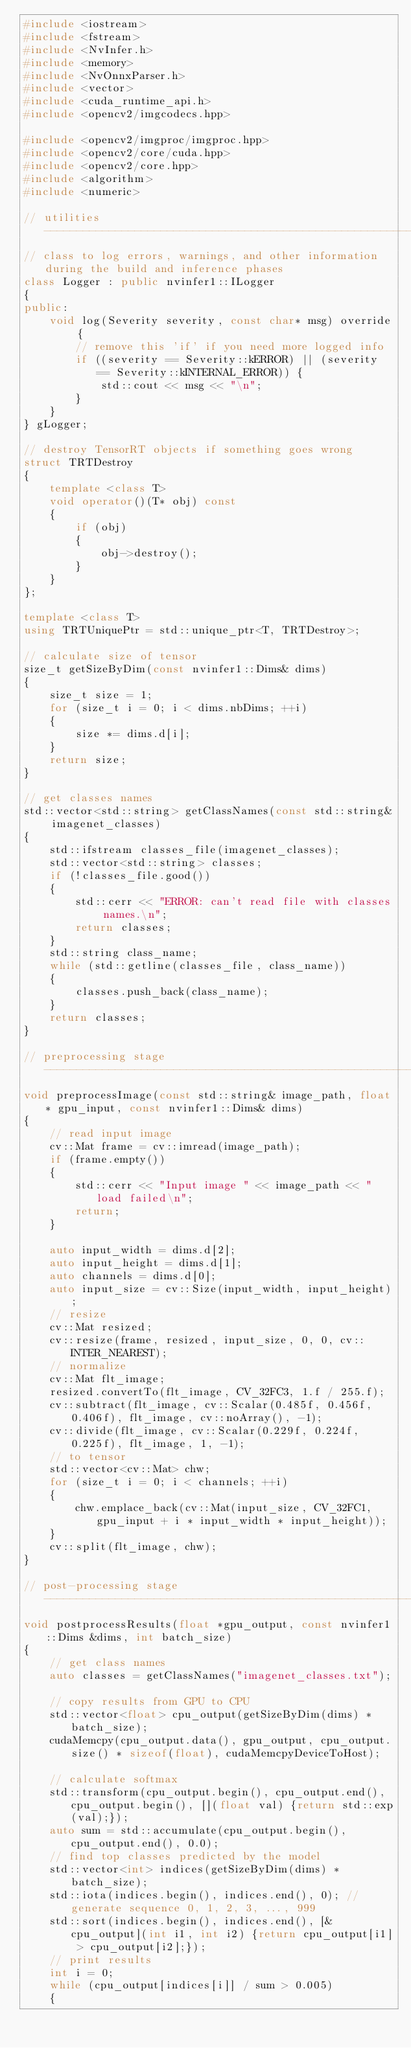Convert code to text. <code><loc_0><loc_0><loc_500><loc_500><_C++_>#include <iostream>
#include <fstream>
#include <NvInfer.h>
#include <memory>
#include <NvOnnxParser.h>
#include <vector>
#include <cuda_runtime_api.h>
#include <opencv2/imgcodecs.hpp>

#include <opencv2/imgproc/imgproc.hpp>
#include <opencv2/core/cuda.hpp>
#include <opencv2/core.hpp>
#include <algorithm>
#include <numeric>

// utilities ----------------------------------------------------------------------------------------------------------
// class to log errors, warnings, and other information during the build and inference phases
class Logger : public nvinfer1::ILogger
{
public:
    void log(Severity severity, const char* msg) override {
        // remove this 'if' if you need more logged info
        if ((severity == Severity::kERROR) || (severity == Severity::kINTERNAL_ERROR)) {
            std::cout << msg << "\n";
        }
    }
} gLogger;

// destroy TensorRT objects if something goes wrong
struct TRTDestroy
{
    template <class T>
    void operator()(T* obj) const
    {
        if (obj)
        {
            obj->destroy();
        }
    }
};

template <class T>
using TRTUniquePtr = std::unique_ptr<T, TRTDestroy>;

// calculate size of tensor
size_t getSizeByDim(const nvinfer1::Dims& dims)
{
    size_t size = 1;
    for (size_t i = 0; i < dims.nbDims; ++i)
    {
        size *= dims.d[i];
    }
    return size;
}

// get classes names
std::vector<std::string> getClassNames(const std::string& imagenet_classes)
{
    std::ifstream classes_file(imagenet_classes);
    std::vector<std::string> classes;
    if (!classes_file.good())
    {
        std::cerr << "ERROR: can't read file with classes names.\n";
        return classes;
    }
    std::string class_name;
    while (std::getline(classes_file, class_name))
    {
        classes.push_back(class_name);
    }
    return classes;
}

// preprocessing stage ------------------------------------------------------------------------------------------------
void preprocessImage(const std::string& image_path, float* gpu_input, const nvinfer1::Dims& dims)
{
    // read input image
    cv::Mat frame = cv::imread(image_path);
    if (frame.empty())
    {
        std::cerr << "Input image " << image_path << " load failed\n";
        return;
    }

    auto input_width = dims.d[2];
    auto input_height = dims.d[1];
    auto channels = dims.d[0];
    auto input_size = cv::Size(input_width, input_height);
    // resize
    cv::Mat resized;
    cv::resize(frame, resized, input_size, 0, 0, cv::INTER_NEAREST);
    // normalize
    cv::Mat flt_image;
    resized.convertTo(flt_image, CV_32FC3, 1.f / 255.f);
    cv::subtract(flt_image, cv::Scalar(0.485f, 0.456f, 0.406f), flt_image, cv::noArray(), -1);
    cv::divide(flt_image, cv::Scalar(0.229f, 0.224f, 0.225f), flt_image, 1, -1);
    // to tensor
    std::vector<cv::Mat> chw;
    for (size_t i = 0; i < channels; ++i)
    {
        chw.emplace_back(cv::Mat(input_size, CV_32FC1, gpu_input + i * input_width * input_height));
    }
    cv::split(flt_image, chw);
}

// post-processing stage ----------------------------------------------------------------------------------------------
void postprocessResults(float *gpu_output, const nvinfer1::Dims &dims, int batch_size)
{
    // get class names
    auto classes = getClassNames("imagenet_classes.txt");

    // copy results from GPU to CPU
    std::vector<float> cpu_output(getSizeByDim(dims) * batch_size);
    cudaMemcpy(cpu_output.data(), gpu_output, cpu_output.size() * sizeof(float), cudaMemcpyDeviceToHost);

    // calculate softmax
    std::transform(cpu_output.begin(), cpu_output.end(), cpu_output.begin(), [](float val) {return std::exp(val);});
    auto sum = std::accumulate(cpu_output.begin(), cpu_output.end(), 0.0);
    // find top classes predicted by the model
    std::vector<int> indices(getSizeByDim(dims) * batch_size);
    std::iota(indices.begin(), indices.end(), 0); // generate sequence 0, 1, 2, 3, ..., 999
    std::sort(indices.begin(), indices.end(), [&cpu_output](int i1, int i2) {return cpu_output[i1] > cpu_output[i2];});
    // print results
    int i = 0;
    while (cpu_output[indices[i]] / sum > 0.005)
    {</code> 